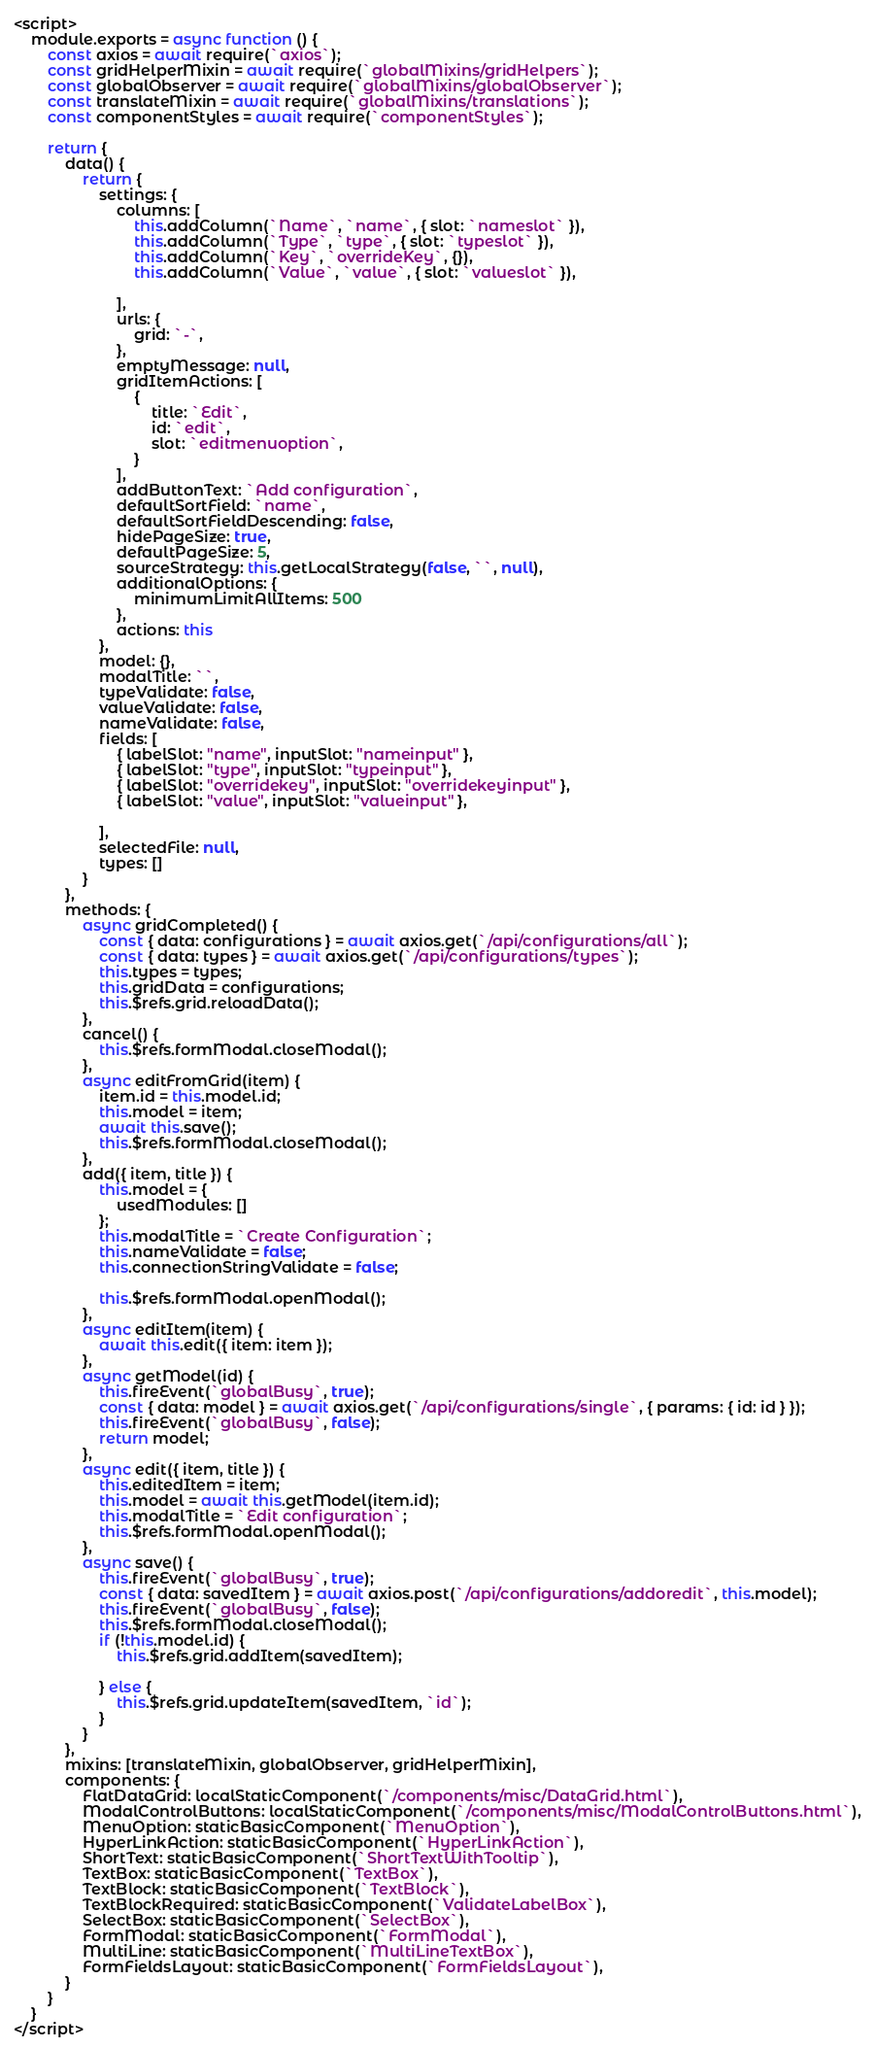Convert code to text. <code><loc_0><loc_0><loc_500><loc_500><_HTML_><script>
    module.exports = async function () {
        const axios = await require(`axios`);
        const gridHelperMixin = await require(`globalMixins/gridHelpers`);
        const globalObserver = await require(`globalMixins/globalObserver`);
        const translateMixin = await require(`globalMixins/translations`);
        const componentStyles = await require(`componentStyles`);

        return {
            data() {
                return {
                    settings: {
                        columns: [
                            this.addColumn(`Name`, `name`, { slot: `nameslot` }),
                            this.addColumn(`Type`, `type`, { slot: `typeslot` }),
                            this.addColumn(`Key`, `overrideKey`, {}),
                            this.addColumn(`Value`, `value`, { slot: `valueslot` }),
                           
                        ],
                        urls: {
                            grid: `-`,
                        },
                        emptyMessage: null,
                        gridItemActions: [
                            {
                                title: `Edit`,
                                id: `edit`,
                                slot: `editmenuoption`,
                            }
                        ],
                        addButtonText: `Add configuration`,
                        defaultSortField: `name`,
                        defaultSortFieldDescending: false,
                        hidePageSize: true,
                        defaultPageSize: 5,
                        sourceStrategy: this.getLocalStrategy(false, ``, null),
                        additionalOptions: {
                            minimumLimitAllItems: 500
                        },
                        actions: this
                    },
                    model: {},
                    modalTitle: ``,
                    typeValidate: false,
                    valueValidate: false,
                    nameValidate: false,
                    fields: [
                        { labelSlot: "name", inputSlot: "nameinput" },
                        { labelSlot: "type", inputSlot: "typeinput" },                      
                        { labelSlot: "overridekey", inputSlot: "overridekeyinput" },
                        { labelSlot: "value", inputSlot: "valueinput" },
                    
                    ],
                    selectedFile: null,
                    types: []
                }
            },
            methods: {
                async gridCompleted() {
                    const { data: configurations } = await axios.get(`/api/configurations/all`);
                    const { data: types } = await axios.get(`/api/configurations/types`);
                    this.types = types;
                    this.gridData = configurations;
                    this.$refs.grid.reloadData();
                },
                cancel() {
                    this.$refs.formModal.closeModal();
                },
                async editFromGrid(item) {
                    item.id = this.model.id;
                    this.model = item;
                    await this.save();
                    this.$refs.formModal.closeModal();
                },
                add({ item, title }) {
                    this.model = {
                        usedModules: []
                    };
                    this.modalTitle = `Create Configuration`;
                    this.nameValidate = false;
                    this.connectionStringValidate = false;

                    this.$refs.formModal.openModal();
                },
                async editItem(item) {
                    await this.edit({ item: item });
                },
                async getModel(id) {
                    this.fireEvent(`globalBusy`, true);
                    const { data: model } = await axios.get(`/api/configurations/single`, { params: { id: id } });
                    this.fireEvent(`globalBusy`, false);
                    return model;
                },
                async edit({ item, title }) {
                    this.editedItem = item;
                    this.model = await this.getModel(item.id);
                    this.modalTitle = `Edit configuration`;
                    this.$refs.formModal.openModal();
                },
                async save() {
                    this.fireEvent(`globalBusy`, true);
                    const { data: savedItem } = await axios.post(`/api/configurations/addoredit`, this.model);
                    this.fireEvent(`globalBusy`, false);
                    this.$refs.formModal.closeModal();
                    if (!this.model.id) {
                        this.$refs.grid.addItem(savedItem);

                    } else {
                        this.$refs.grid.updateItem(savedItem, `id`);
                    }
                }
            },
            mixins: [translateMixin, globalObserver, gridHelperMixin],
            components: {
                FlatDataGrid: localStaticComponent(`/components/misc/DataGrid.html`),
                ModalControlButtons: localStaticComponent(`/components/misc/ModalControlButtons.html`),
                MenuOption: staticBasicComponent(`MenuOption`),
                HyperLinkAction: staticBasicComponent(`HyperLinkAction`),
                ShortText: staticBasicComponent(`ShortTextWithTooltip`),
                TextBox: staticBasicComponent(`TextBox`),
                TextBlock: staticBasicComponent(`TextBlock`),
                TextBlockRequired: staticBasicComponent(`ValidateLabelBox`),
                SelectBox: staticBasicComponent(`SelectBox`),
                FormModal: staticBasicComponent(`FormModal`),
                MultiLine: staticBasicComponent(`MultiLineTextBox`),
                FormFieldsLayout: staticBasicComponent(`FormFieldsLayout`),
            }
        }
    }
</script></code> 